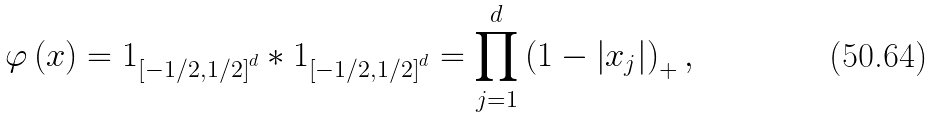Convert formula to latex. <formula><loc_0><loc_0><loc_500><loc_500>\varphi \left ( x \right ) = 1 _ { \left [ - 1 / 2 , 1 / 2 \right ] ^ { d } } \ast 1 _ { \left [ - 1 / 2 , 1 / 2 \right ] ^ { d } } = \prod _ { j = 1 } ^ { d } \left ( 1 - \left | x _ { j } \right | \right ) _ { + } ,</formula> 